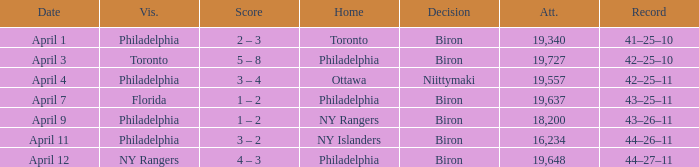Who were the visitors when the home team were the ny rangers? Philadelphia. 